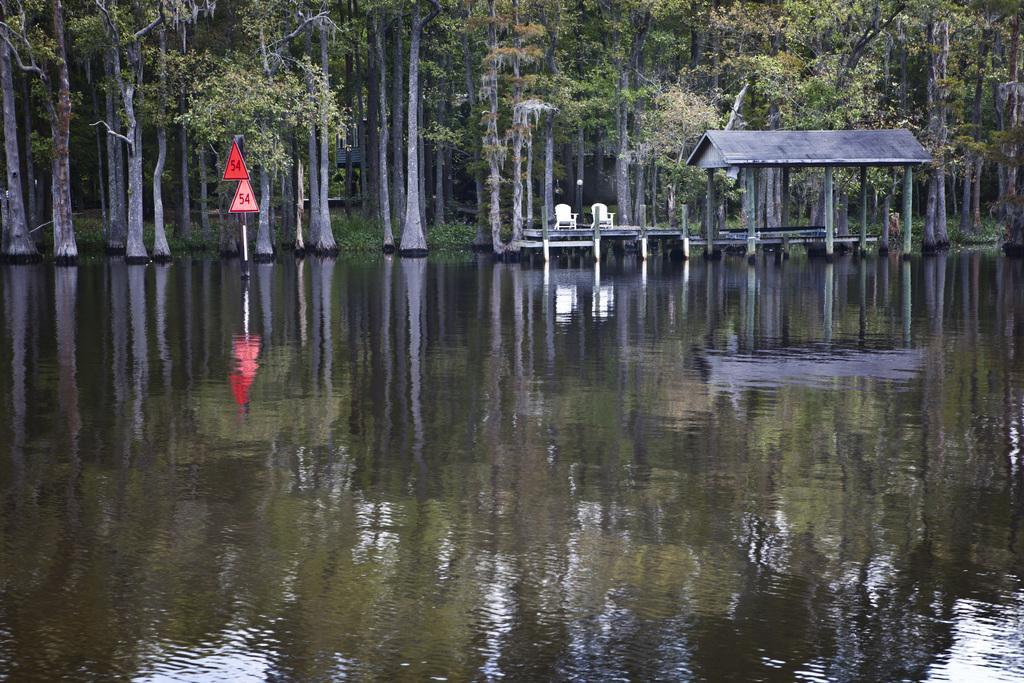Could you give a brief overview of what you see in this image? In this image I can see the water. To the right there is a shed on the water. I can also see two chairs in the back. There are many trees and two red color boards to the pole. 